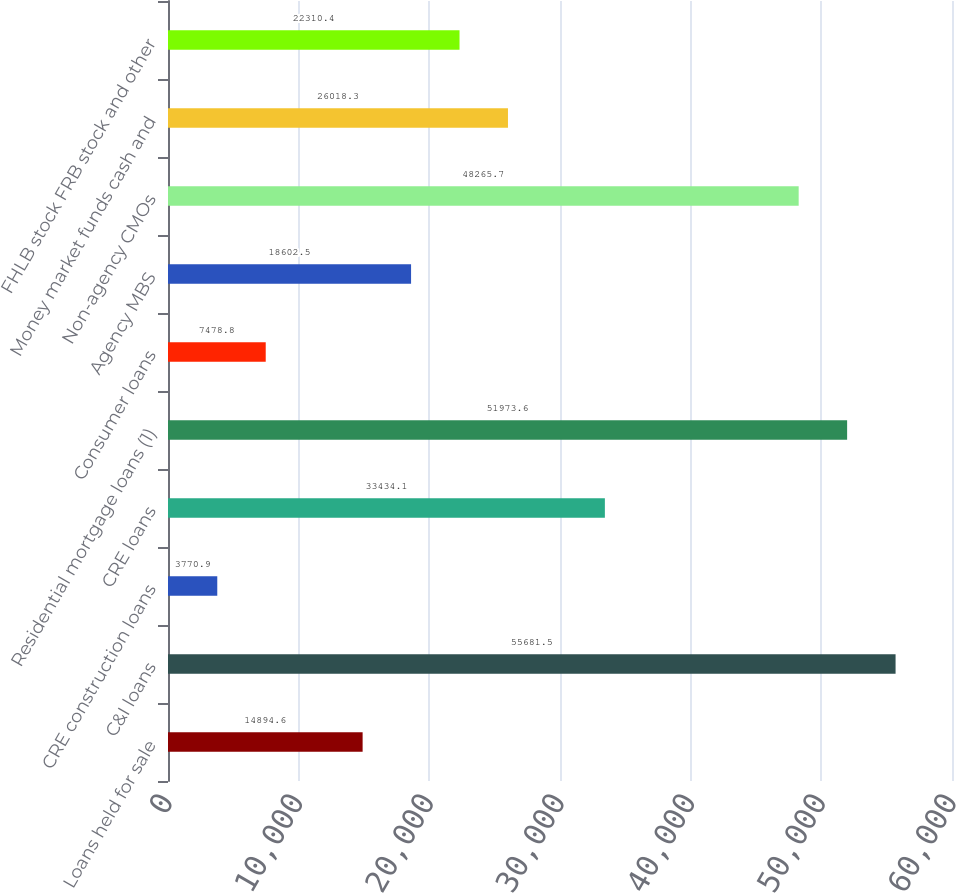Convert chart to OTSL. <chart><loc_0><loc_0><loc_500><loc_500><bar_chart><fcel>Loans held for sale<fcel>C&I loans<fcel>CRE construction loans<fcel>CRE loans<fcel>Residential mortgage loans (1)<fcel>Consumer loans<fcel>Agency MBS<fcel>Non-agency CMOs<fcel>Money market funds cash and<fcel>FHLB stock FRB stock and other<nl><fcel>14894.6<fcel>55681.5<fcel>3770.9<fcel>33434.1<fcel>51973.6<fcel>7478.8<fcel>18602.5<fcel>48265.7<fcel>26018.3<fcel>22310.4<nl></chart> 